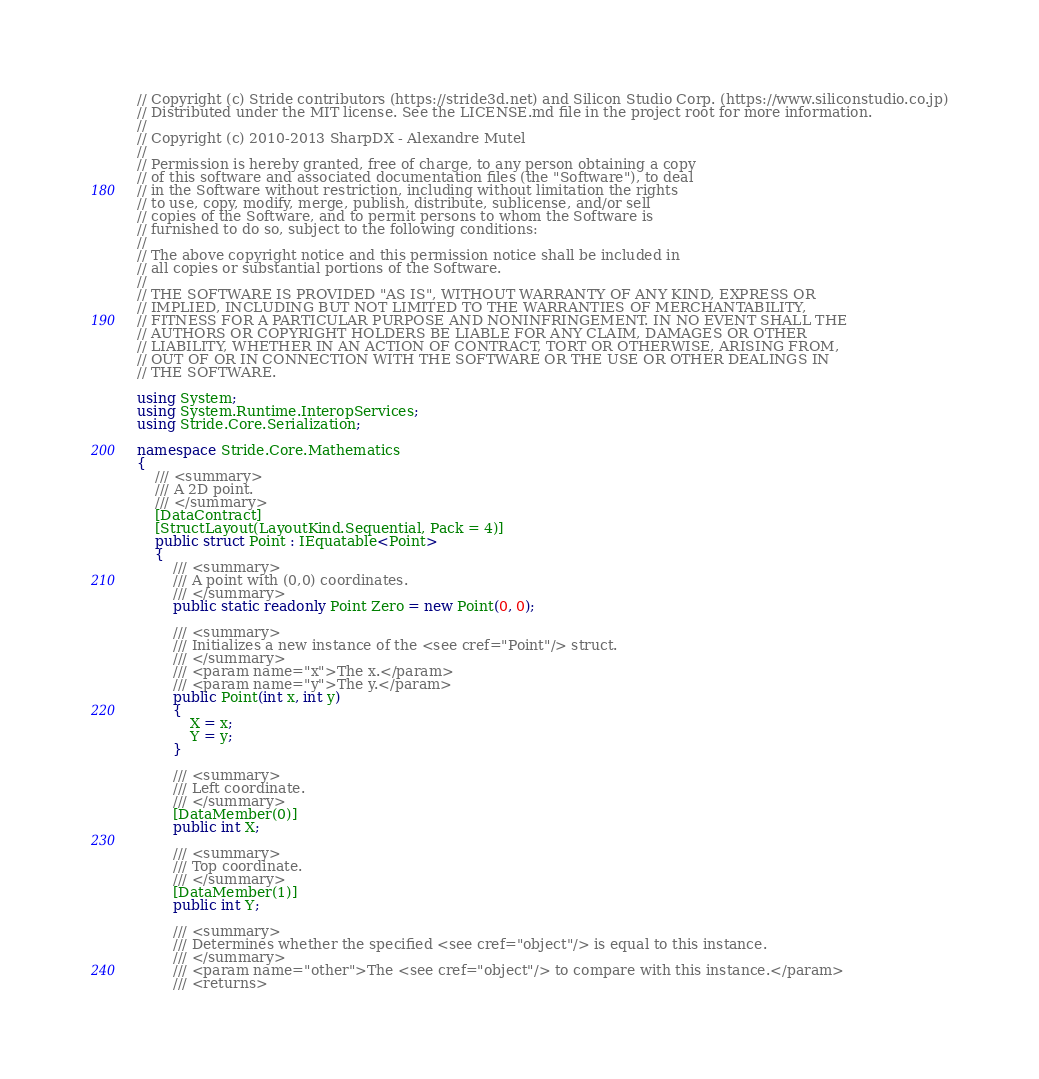<code> <loc_0><loc_0><loc_500><loc_500><_C#_>// Copyright (c) Stride contributors (https://stride3d.net) and Silicon Studio Corp. (https://www.siliconstudio.co.jp)
// Distributed under the MIT license. See the LICENSE.md file in the project root for more information.
//
// Copyright (c) 2010-2013 SharpDX - Alexandre Mutel
//
// Permission is hereby granted, free of charge, to any person obtaining a copy
// of this software and associated documentation files (the "Software"), to deal
// in the Software without restriction, including without limitation the rights
// to use, copy, modify, merge, publish, distribute, sublicense, and/or sell
// copies of the Software, and to permit persons to whom the Software is
// furnished to do so, subject to the following conditions:
//
// The above copyright notice and this permission notice shall be included in
// all copies or substantial portions of the Software.
//
// THE SOFTWARE IS PROVIDED "AS IS", WITHOUT WARRANTY OF ANY KIND, EXPRESS OR
// IMPLIED, INCLUDING BUT NOT LIMITED TO THE WARRANTIES OF MERCHANTABILITY,
// FITNESS FOR A PARTICULAR PURPOSE AND NONINFRINGEMENT. IN NO EVENT SHALL THE
// AUTHORS OR COPYRIGHT HOLDERS BE LIABLE FOR ANY CLAIM, DAMAGES OR OTHER
// LIABILITY, WHETHER IN AN ACTION OF CONTRACT, TORT OR OTHERWISE, ARISING FROM,
// OUT OF OR IN CONNECTION WITH THE SOFTWARE OR THE USE OR OTHER DEALINGS IN
// THE SOFTWARE.

using System;
using System.Runtime.InteropServices;
using Stride.Core.Serialization;

namespace Stride.Core.Mathematics
{
    /// <summary>
    /// A 2D point.
    /// </summary>
    [DataContract]
    [StructLayout(LayoutKind.Sequential, Pack = 4)]
    public struct Point : IEquatable<Point>
    {
        /// <summary>
        /// A point with (0,0) coordinates.
        /// </summary>
        public static readonly Point Zero = new Point(0, 0);

        /// <summary>
        /// Initializes a new instance of the <see cref="Point"/> struct.
        /// </summary>
        /// <param name="x">The x.</param>
        /// <param name="y">The y.</param>
        public Point(int x, int y)
        {
            X = x;
            Y = y;
        }

        /// <summary>
        /// Left coordinate.
        /// </summary>
        [DataMember(0)]
        public int X;

        /// <summary>
        /// Top coordinate.
        /// </summary>
        [DataMember(1)]
        public int Y;

        /// <summary>
        /// Determines whether the specified <see cref="object"/> is equal to this instance.
        /// </summary>
        /// <param name="other">The <see cref="object"/> to compare with this instance.</param>
        /// <returns></code> 